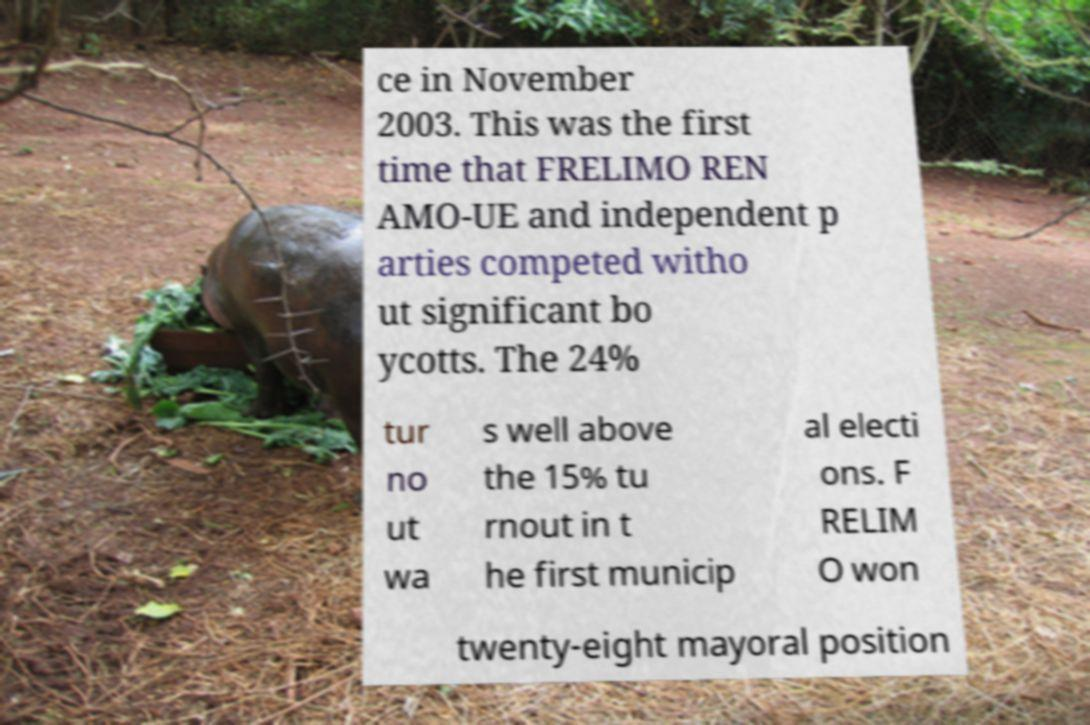I need the written content from this picture converted into text. Can you do that? ce in November 2003. This was the first time that FRELIMO REN AMO-UE and independent p arties competed witho ut significant bo ycotts. The 24% tur no ut wa s well above the 15% tu rnout in t he first municip al electi ons. F RELIM O won twenty-eight mayoral position 